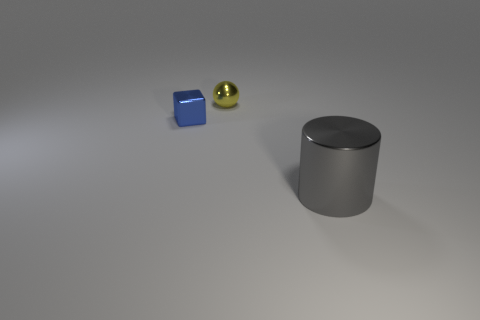Add 3 gray rubber cubes. How many objects exist? 6 Subtract all spheres. How many objects are left? 2 Add 2 big gray cylinders. How many big gray cylinders are left? 3 Add 3 tiny blue metal blocks. How many tiny blue metal blocks exist? 4 Subtract 0 cyan balls. How many objects are left? 3 Subtract all big cyan matte balls. Subtract all blue objects. How many objects are left? 2 